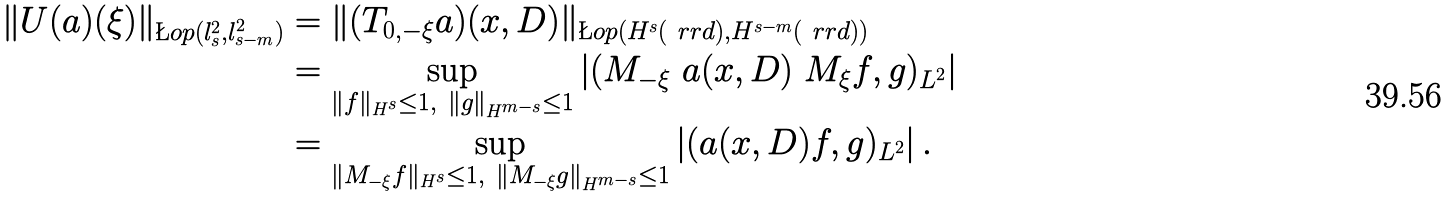Convert formula to latex. <formula><loc_0><loc_0><loc_500><loc_500>\| U ( a ) ( \xi ) \| _ { \L o p ( l _ { s } ^ { 2 } , l _ { s - m } ^ { 2 } ) } & = \| ( T _ { 0 , - \xi } a ) ( x , D ) \| _ { \L o p ( H ^ { s } ( \ r r d ) , H ^ { s - m } ( \ r r d ) ) } \\ & = \sup _ { \| f \| _ { H ^ { s } } \leq 1 , \ \| g \| _ { H ^ { m - s } } \leq 1 } \left | ( M _ { - \xi } \ a ( x , D ) \ M _ { \xi } f , g ) _ { L ^ { 2 } } \right | \\ & = \sup _ { \| M _ { - \xi } f \| _ { H ^ { s } } \leq 1 , \ \| M _ { - \xi } g \| _ { H ^ { m - s } } \leq 1 } \left | ( a ( x , D ) f , g ) _ { L ^ { 2 } } \right | .</formula> 